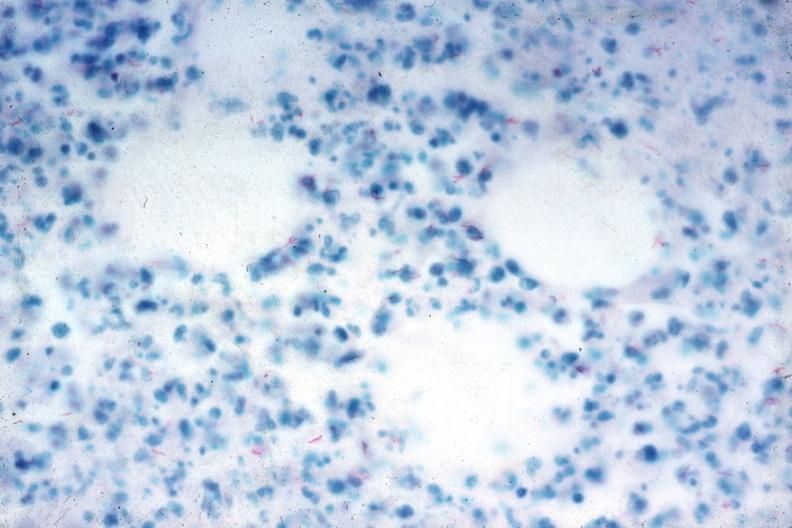do retroperitoneum stain stain numerous acid fast bacilli very good slide?
Answer the question using a single word or phrase. No 